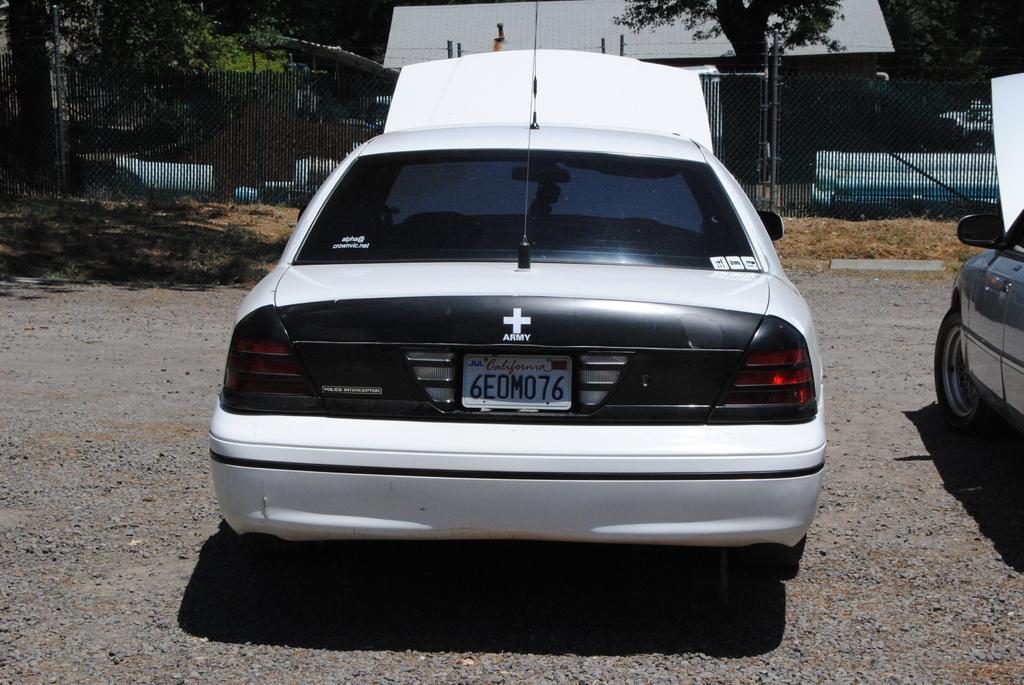Describe this image in one or two sentences. In this image we can see some cars on the ground. We can also see some stones, plants, the metal fence, some poles, a house with a roof and a group of trees. 